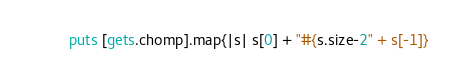<code> <loc_0><loc_0><loc_500><loc_500><_Ruby_>puts [gets.chomp].map{|s| s[0] + "#{s.size-2" + s[-1]}</code> 